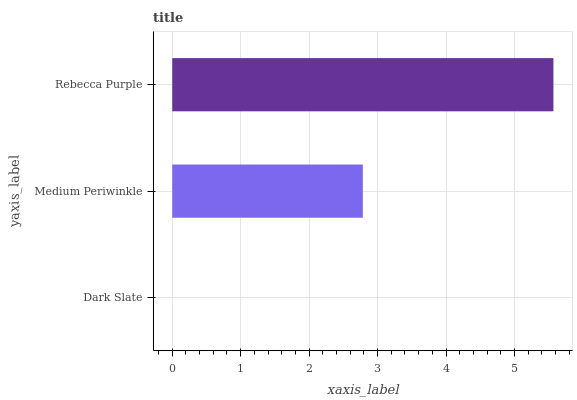Is Dark Slate the minimum?
Answer yes or no. Yes. Is Rebecca Purple the maximum?
Answer yes or no. Yes. Is Medium Periwinkle the minimum?
Answer yes or no. No. Is Medium Periwinkle the maximum?
Answer yes or no. No. Is Medium Periwinkle greater than Dark Slate?
Answer yes or no. Yes. Is Dark Slate less than Medium Periwinkle?
Answer yes or no. Yes. Is Dark Slate greater than Medium Periwinkle?
Answer yes or no. No. Is Medium Periwinkle less than Dark Slate?
Answer yes or no. No. Is Medium Periwinkle the high median?
Answer yes or no. Yes. Is Medium Periwinkle the low median?
Answer yes or no. Yes. Is Dark Slate the high median?
Answer yes or no. No. Is Dark Slate the low median?
Answer yes or no. No. 